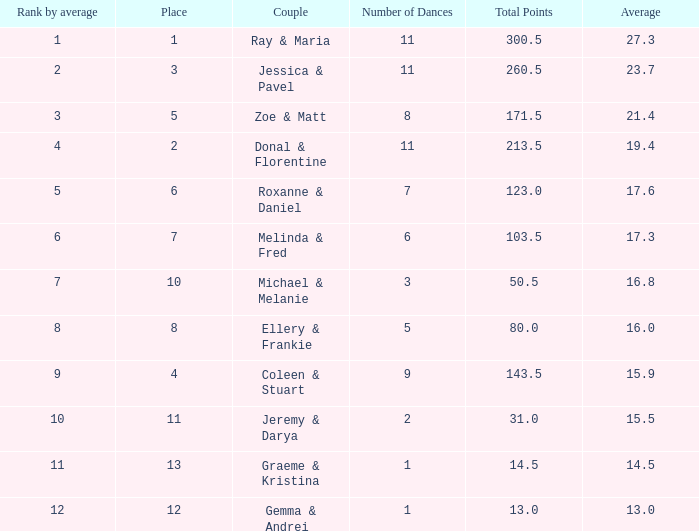Write the full table. {'header': ['Rank by average', 'Place', 'Couple', 'Number of Dances', 'Total Points', 'Average'], 'rows': [['1', '1', 'Ray & Maria', '11', '300.5', '27.3'], ['2', '3', 'Jessica & Pavel', '11', '260.5', '23.7'], ['3', '5', 'Zoe & Matt', '8', '171.5', '21.4'], ['4', '2', 'Donal & Florentine', '11', '213.5', '19.4'], ['5', '6', 'Roxanne & Daniel', '7', '123.0', '17.6'], ['6', '7', 'Melinda & Fred', '6', '103.5', '17.3'], ['7', '10', 'Michael & Melanie', '3', '50.5', '16.8'], ['8', '8', 'Ellery & Frankie', '5', '80.0', '16.0'], ['9', '4', 'Coleen & Stuart', '9', '143.5', '15.9'], ['10', '11', 'Jeremy & Darya', '2', '31.0', '15.5'], ['11', '13', 'Graeme & Kristina', '1', '14.5', '14.5'], ['12', '12', 'Gemma & Andrei', '1', '13.0', '13.0']]} What is the couples name where the average is 15.9? Coleen & Stuart. 